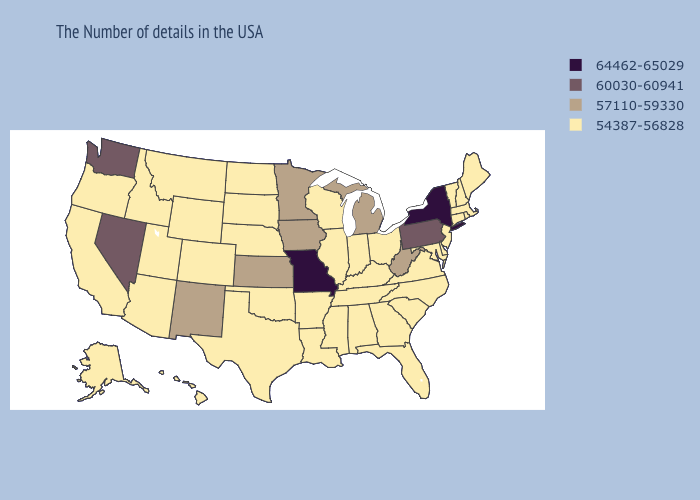Among the states that border Wyoming , which have the highest value?
Keep it brief. Nebraska, South Dakota, Colorado, Utah, Montana, Idaho. Does Alaska have the lowest value in the USA?
Give a very brief answer. Yes. What is the lowest value in the MidWest?
Concise answer only. 54387-56828. What is the value of Ohio?
Give a very brief answer. 54387-56828. Does Minnesota have a higher value than Alaska?
Answer briefly. Yes. What is the highest value in states that border New Mexico?
Concise answer only. 54387-56828. What is the value of Alaska?
Give a very brief answer. 54387-56828. Does Arkansas have the highest value in the USA?
Write a very short answer. No. What is the value of Washington?
Be succinct. 60030-60941. Name the states that have a value in the range 54387-56828?
Be succinct. Maine, Massachusetts, Rhode Island, New Hampshire, Vermont, Connecticut, New Jersey, Delaware, Maryland, Virginia, North Carolina, South Carolina, Ohio, Florida, Georgia, Kentucky, Indiana, Alabama, Tennessee, Wisconsin, Illinois, Mississippi, Louisiana, Arkansas, Nebraska, Oklahoma, Texas, South Dakota, North Dakota, Wyoming, Colorado, Utah, Montana, Arizona, Idaho, California, Oregon, Alaska, Hawaii. What is the highest value in the West ?
Write a very short answer. 60030-60941. Does the first symbol in the legend represent the smallest category?
Write a very short answer. No. Among the states that border Maine , which have the highest value?
Quick response, please. New Hampshire. Name the states that have a value in the range 57110-59330?
Write a very short answer. West Virginia, Michigan, Minnesota, Iowa, Kansas, New Mexico. Does North Dakota have the highest value in the MidWest?
Short answer required. No. 